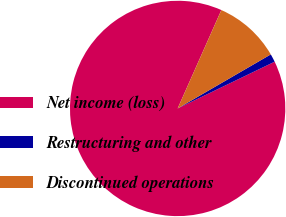Convert chart to OTSL. <chart><loc_0><loc_0><loc_500><loc_500><pie_chart><fcel>Net income (loss)<fcel>Restructuring and other<fcel>Discontinued operations<nl><fcel>88.8%<fcel>1.22%<fcel>9.98%<nl></chart> 